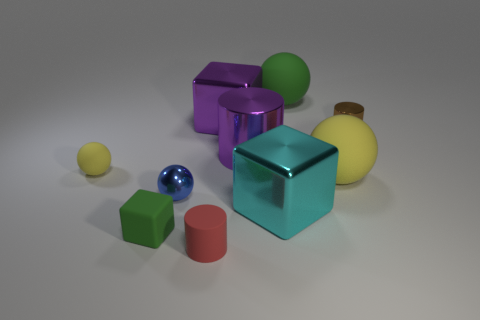How do the textures of the different objects compare? The objects display a variety of textures. The metal cubes have a smooth and reflective surface, while the spheres seem matte and slightly textured. The green cube appears solid and has a consistent surface, and the cylindrical object has a reflective, smooth texture akin to plastic. 